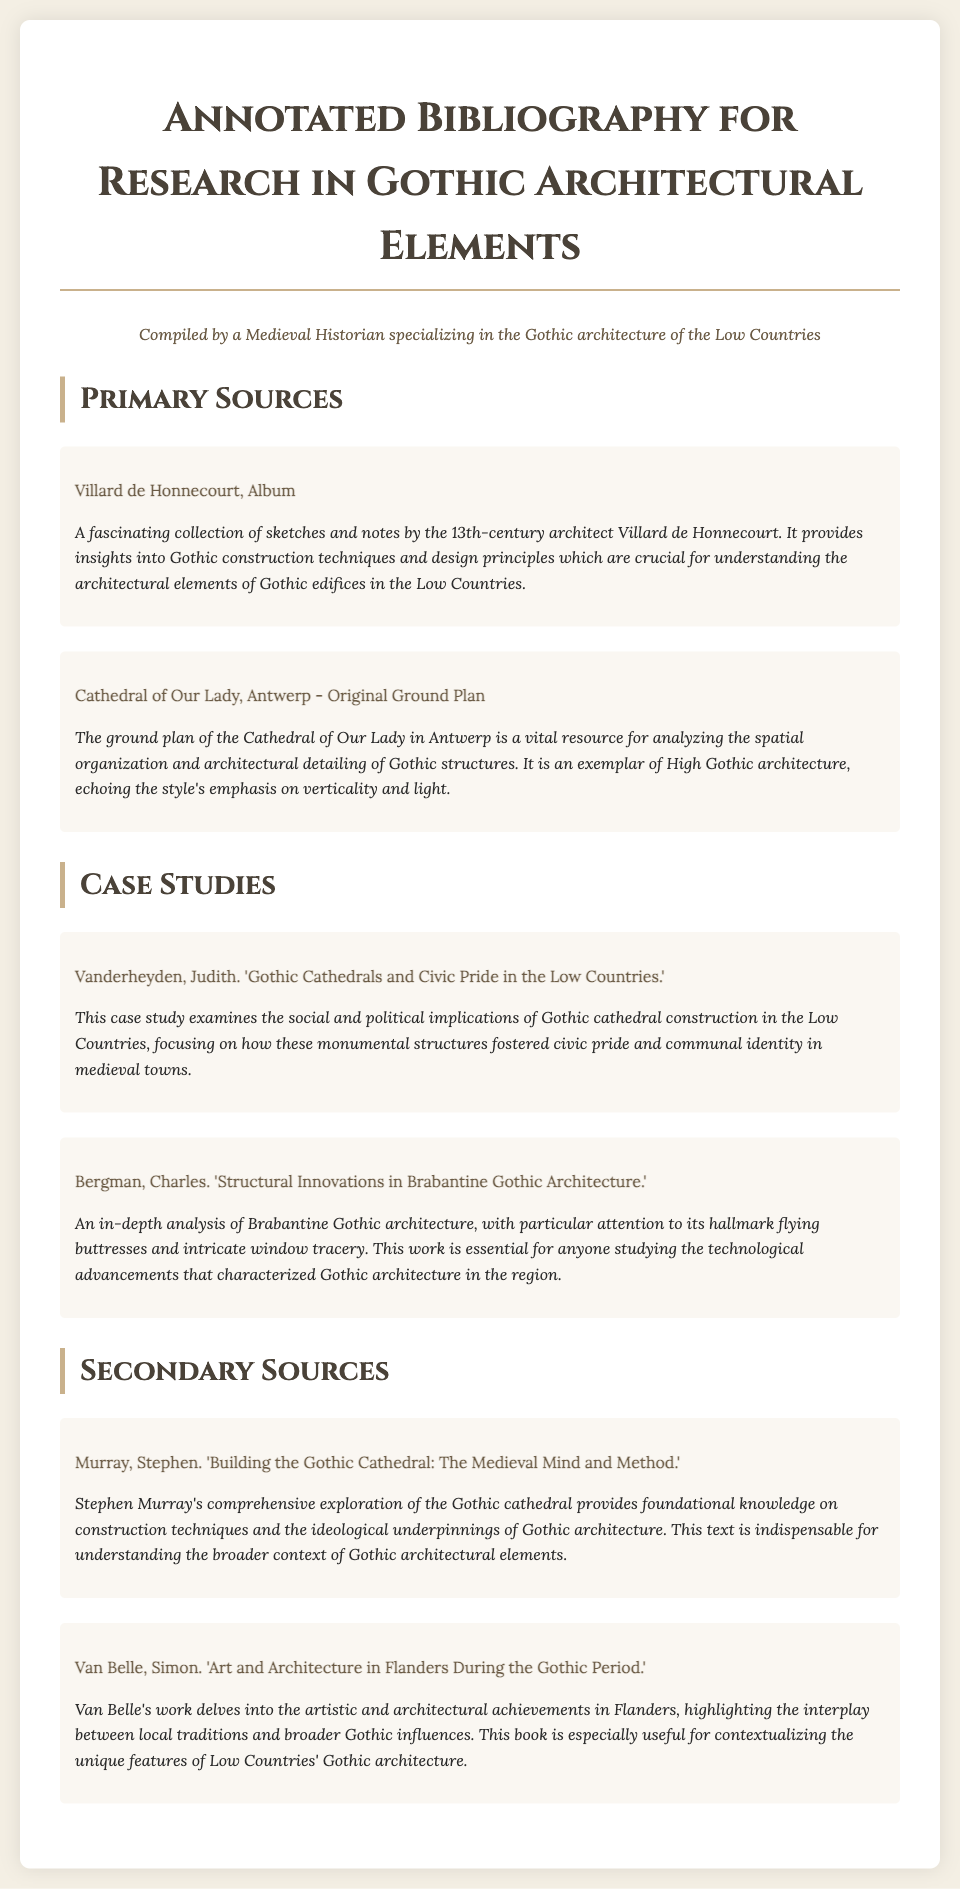What is the title of the document? The title of the document is prominently displayed at the top as the main heading.
Answer: Annotated Bibliography for Research in Gothic Architectural Elements Who authored the "Album"? The document mentions the creator of the "Album" in the primary sources section.
Answer: Villard de Honnecourt What style is the Cathedral of Our Lady in Antwerp associated with? The description of the Cathedral of Our Lady specifies its architectural style.
Answer: High Gothic Who analyzed the "Structural Innovations in Brabantine Gothic Architecture"? The case study section attributes this analysis to a specific author.
Answer: Charles Bergman What is the focus of Judith Vanderheyden's case study? The case study summary describes the main theme of Vanderheyden's work.
Answer: Civic Pride Which secondary source discusses the ideological aspects of Gothic architecture? The secondary sources section refers to a specific source covering this topic.
Answer: Stephen Murray's "Building the Gothic Cathedral: The Medieval Mind and Method" 